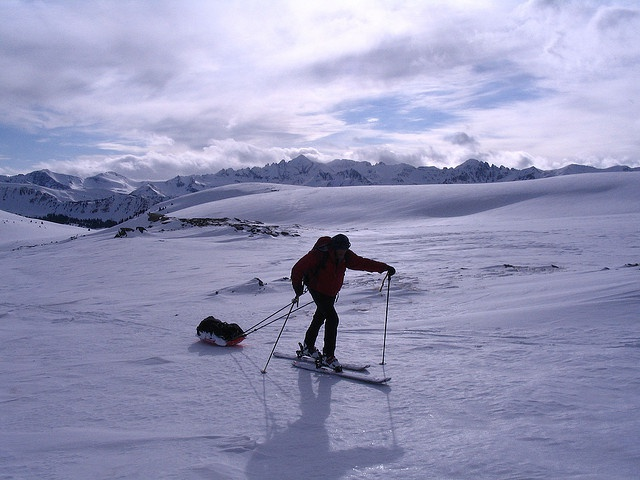Describe the objects in this image and their specific colors. I can see people in lavender, black, gray, and darkgray tones, backpack in lavender, black, purple, navy, and darkgray tones, and skis in lavender, purple, gray, navy, and black tones in this image. 